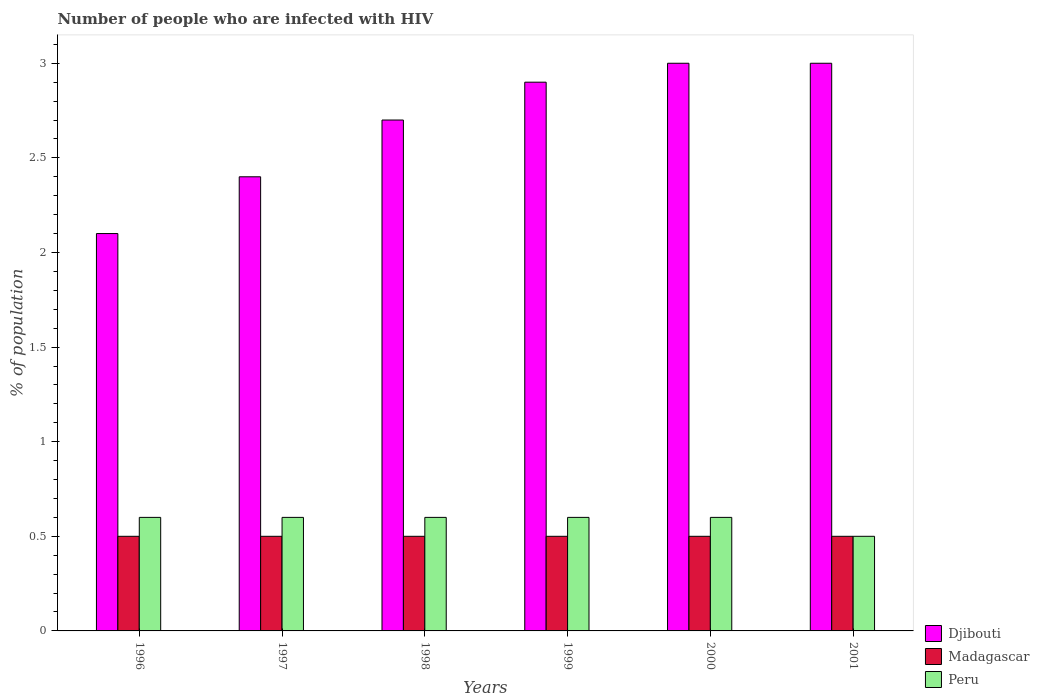How many groups of bars are there?
Your response must be concise. 6. Are the number of bars per tick equal to the number of legend labels?
Offer a terse response. Yes. How many bars are there on the 5th tick from the right?
Offer a very short reply. 3. What is the label of the 5th group of bars from the left?
Ensure brevity in your answer.  2000. Across all years, what is the maximum percentage of HIV infected population in in Madagascar?
Offer a very short reply. 0.5. Across all years, what is the minimum percentage of HIV infected population in in Peru?
Your answer should be compact. 0.5. In which year was the percentage of HIV infected population in in Djibouti maximum?
Give a very brief answer. 2000. What is the total percentage of HIV infected population in in Peru in the graph?
Your response must be concise. 3.5. What is the difference between the percentage of HIV infected population in in Peru in 1996 and that in 1997?
Offer a very short reply. 0. What is the average percentage of HIV infected population in in Peru per year?
Your response must be concise. 0.58. In the year 2000, what is the difference between the percentage of HIV infected population in in Madagascar and percentage of HIV infected population in in Djibouti?
Your answer should be very brief. -2.5. What is the ratio of the percentage of HIV infected population in in Djibouti in 1999 to that in 2001?
Your answer should be very brief. 0.97. Is the difference between the percentage of HIV infected population in in Madagascar in 1997 and 1999 greater than the difference between the percentage of HIV infected population in in Djibouti in 1997 and 1999?
Your response must be concise. Yes. What is the difference between the highest and the lowest percentage of HIV infected population in in Djibouti?
Provide a short and direct response. 0.9. In how many years, is the percentage of HIV infected population in in Djibouti greater than the average percentage of HIV infected population in in Djibouti taken over all years?
Provide a short and direct response. 4. Is the sum of the percentage of HIV infected population in in Peru in 1998 and 1999 greater than the maximum percentage of HIV infected population in in Madagascar across all years?
Ensure brevity in your answer.  Yes. What does the 2nd bar from the left in 1999 represents?
Provide a short and direct response. Madagascar. What does the 2nd bar from the right in 1996 represents?
Ensure brevity in your answer.  Madagascar. Is it the case that in every year, the sum of the percentage of HIV infected population in in Madagascar and percentage of HIV infected population in in Peru is greater than the percentage of HIV infected population in in Djibouti?
Give a very brief answer. No. How many years are there in the graph?
Make the answer very short. 6. Does the graph contain any zero values?
Give a very brief answer. No. How are the legend labels stacked?
Provide a short and direct response. Vertical. What is the title of the graph?
Make the answer very short. Number of people who are infected with HIV. What is the label or title of the X-axis?
Provide a succinct answer. Years. What is the label or title of the Y-axis?
Keep it short and to the point. % of population. What is the % of population in Djibouti in 1996?
Offer a terse response. 2.1. What is the % of population of Peru in 1996?
Your response must be concise. 0.6. What is the % of population of Djibouti in 1997?
Offer a terse response. 2.4. What is the % of population in Madagascar in 1998?
Give a very brief answer. 0.5. What is the % of population in Djibouti in 1999?
Your answer should be very brief. 2.9. What is the % of population in Peru in 1999?
Offer a terse response. 0.6. What is the % of population of Peru in 2000?
Offer a terse response. 0.6. What is the % of population in Madagascar in 2001?
Make the answer very short. 0.5. Across all years, what is the maximum % of population in Djibouti?
Ensure brevity in your answer.  3. Across all years, what is the maximum % of population in Madagascar?
Provide a short and direct response. 0.5. Across all years, what is the maximum % of population in Peru?
Make the answer very short. 0.6. Across all years, what is the minimum % of population in Madagascar?
Provide a succinct answer. 0.5. Across all years, what is the minimum % of population in Peru?
Ensure brevity in your answer.  0.5. What is the difference between the % of population of Madagascar in 1996 and that in 1997?
Provide a short and direct response. 0. What is the difference between the % of population of Djibouti in 1996 and that in 1998?
Offer a terse response. -0.6. What is the difference between the % of population of Djibouti in 1996 and that in 1999?
Offer a terse response. -0.8. What is the difference between the % of population in Djibouti in 1996 and that in 2000?
Offer a terse response. -0.9. What is the difference between the % of population in Madagascar in 1996 and that in 2000?
Your answer should be compact. 0. What is the difference between the % of population of Djibouti in 1996 and that in 2001?
Offer a very short reply. -0.9. What is the difference between the % of population of Peru in 1996 and that in 2001?
Your answer should be very brief. 0.1. What is the difference between the % of population in Djibouti in 1997 and that in 1998?
Make the answer very short. -0.3. What is the difference between the % of population in Madagascar in 1997 and that in 1998?
Offer a very short reply. 0. What is the difference between the % of population in Djibouti in 1997 and that in 2000?
Keep it short and to the point. -0.6. What is the difference between the % of population in Madagascar in 1997 and that in 2001?
Offer a terse response. 0. What is the difference between the % of population of Djibouti in 1998 and that in 1999?
Provide a succinct answer. -0.2. What is the difference between the % of population of Madagascar in 1998 and that in 1999?
Your response must be concise. 0. What is the difference between the % of population of Peru in 1998 and that in 1999?
Keep it short and to the point. 0. What is the difference between the % of population in Djibouti in 1998 and that in 2000?
Offer a very short reply. -0.3. What is the difference between the % of population of Madagascar in 1998 and that in 2000?
Provide a short and direct response. 0. What is the difference between the % of population of Peru in 1998 and that in 2001?
Your answer should be very brief. 0.1. What is the difference between the % of population in Madagascar in 1999 and that in 2000?
Your answer should be compact. 0. What is the difference between the % of population of Madagascar in 1999 and that in 2001?
Keep it short and to the point. 0. What is the difference between the % of population in Peru in 2000 and that in 2001?
Offer a terse response. 0.1. What is the difference between the % of population of Djibouti in 1996 and the % of population of Madagascar in 1997?
Offer a terse response. 1.6. What is the difference between the % of population of Djibouti in 1996 and the % of population of Madagascar in 1998?
Your answer should be compact. 1.6. What is the difference between the % of population in Djibouti in 1996 and the % of population in Peru in 1998?
Your answer should be very brief. 1.5. What is the difference between the % of population of Madagascar in 1996 and the % of population of Peru in 1998?
Your answer should be very brief. -0.1. What is the difference between the % of population of Madagascar in 1996 and the % of population of Peru in 1999?
Offer a very short reply. -0.1. What is the difference between the % of population of Djibouti in 1996 and the % of population of Madagascar in 2000?
Offer a terse response. 1.6. What is the difference between the % of population of Djibouti in 1996 and the % of population of Peru in 2000?
Provide a short and direct response. 1.5. What is the difference between the % of population in Djibouti in 1996 and the % of population in Peru in 2001?
Ensure brevity in your answer.  1.6. What is the difference between the % of population in Djibouti in 1997 and the % of population in Madagascar in 1998?
Your answer should be compact. 1.9. What is the difference between the % of population of Djibouti in 1997 and the % of population of Peru in 1998?
Offer a terse response. 1.8. What is the difference between the % of population of Djibouti in 1997 and the % of population of Peru in 1999?
Keep it short and to the point. 1.8. What is the difference between the % of population of Djibouti in 1997 and the % of population of Madagascar in 2000?
Your answer should be compact. 1.9. What is the difference between the % of population of Djibouti in 1997 and the % of population of Peru in 2000?
Provide a short and direct response. 1.8. What is the difference between the % of population in Madagascar in 1997 and the % of population in Peru in 2000?
Offer a terse response. -0.1. What is the difference between the % of population in Madagascar in 1998 and the % of population in Peru in 1999?
Ensure brevity in your answer.  -0.1. What is the difference between the % of population in Djibouti in 1998 and the % of population in Peru in 2000?
Your answer should be very brief. 2.1. What is the difference between the % of population in Madagascar in 1998 and the % of population in Peru in 2000?
Your response must be concise. -0.1. What is the difference between the % of population of Djibouti in 1998 and the % of population of Peru in 2001?
Make the answer very short. 2.2. What is the difference between the % of population in Djibouti in 1999 and the % of population in Peru in 2000?
Keep it short and to the point. 2.3. What is the difference between the % of population of Djibouti in 1999 and the % of population of Madagascar in 2001?
Your answer should be compact. 2.4. What is the difference between the % of population in Djibouti in 1999 and the % of population in Peru in 2001?
Provide a short and direct response. 2.4. What is the difference between the % of population of Madagascar in 1999 and the % of population of Peru in 2001?
Give a very brief answer. 0. What is the difference between the % of population in Djibouti in 2000 and the % of population in Peru in 2001?
Your answer should be very brief. 2.5. What is the difference between the % of population of Madagascar in 2000 and the % of population of Peru in 2001?
Ensure brevity in your answer.  0. What is the average % of population in Djibouti per year?
Make the answer very short. 2.68. What is the average % of population of Peru per year?
Keep it short and to the point. 0.58. In the year 1996, what is the difference between the % of population in Madagascar and % of population in Peru?
Offer a very short reply. -0.1. In the year 1997, what is the difference between the % of population of Djibouti and % of population of Peru?
Your answer should be very brief. 1.8. In the year 1998, what is the difference between the % of population of Madagascar and % of population of Peru?
Your answer should be compact. -0.1. In the year 1999, what is the difference between the % of population in Djibouti and % of population in Madagascar?
Keep it short and to the point. 2.4. In the year 1999, what is the difference between the % of population of Djibouti and % of population of Peru?
Offer a terse response. 2.3. In the year 2000, what is the difference between the % of population of Djibouti and % of population of Madagascar?
Keep it short and to the point. 2.5. In the year 2000, what is the difference between the % of population of Djibouti and % of population of Peru?
Give a very brief answer. 2.4. In the year 2001, what is the difference between the % of population in Djibouti and % of population in Madagascar?
Offer a very short reply. 2.5. What is the ratio of the % of population of Madagascar in 1996 to that in 1997?
Offer a very short reply. 1. What is the ratio of the % of population of Peru in 1996 to that in 1997?
Your response must be concise. 1. What is the ratio of the % of population of Djibouti in 1996 to that in 1998?
Provide a short and direct response. 0.78. What is the ratio of the % of population in Peru in 1996 to that in 1998?
Your answer should be compact. 1. What is the ratio of the % of population in Djibouti in 1996 to that in 1999?
Provide a succinct answer. 0.72. What is the ratio of the % of population in Madagascar in 1996 to that in 1999?
Offer a very short reply. 1. What is the ratio of the % of population of Madagascar in 1996 to that in 2000?
Give a very brief answer. 1. What is the ratio of the % of population in Djibouti in 1996 to that in 2001?
Ensure brevity in your answer.  0.7. What is the ratio of the % of population of Madagascar in 1996 to that in 2001?
Your response must be concise. 1. What is the ratio of the % of population of Djibouti in 1997 to that in 1998?
Give a very brief answer. 0.89. What is the ratio of the % of population in Madagascar in 1997 to that in 1998?
Your response must be concise. 1. What is the ratio of the % of population in Djibouti in 1997 to that in 1999?
Ensure brevity in your answer.  0.83. What is the ratio of the % of population in Madagascar in 1997 to that in 1999?
Your answer should be very brief. 1. What is the ratio of the % of population of Peru in 1997 to that in 1999?
Offer a very short reply. 1. What is the ratio of the % of population of Madagascar in 1997 to that in 2000?
Ensure brevity in your answer.  1. What is the ratio of the % of population of Madagascar in 1997 to that in 2001?
Offer a terse response. 1. What is the ratio of the % of population of Peru in 1997 to that in 2001?
Give a very brief answer. 1.2. What is the ratio of the % of population of Peru in 1998 to that in 1999?
Provide a succinct answer. 1. What is the ratio of the % of population in Djibouti in 1998 to that in 2000?
Provide a short and direct response. 0.9. What is the ratio of the % of population in Madagascar in 1998 to that in 2000?
Provide a short and direct response. 1. What is the ratio of the % of population of Djibouti in 1998 to that in 2001?
Give a very brief answer. 0.9. What is the ratio of the % of population in Madagascar in 1998 to that in 2001?
Give a very brief answer. 1. What is the ratio of the % of population in Peru in 1998 to that in 2001?
Ensure brevity in your answer.  1.2. What is the ratio of the % of population of Djibouti in 1999 to that in 2000?
Your answer should be very brief. 0.97. What is the ratio of the % of population in Madagascar in 1999 to that in 2000?
Offer a very short reply. 1. What is the ratio of the % of population of Djibouti in 1999 to that in 2001?
Make the answer very short. 0.97. What is the ratio of the % of population of Madagascar in 1999 to that in 2001?
Offer a very short reply. 1. What is the ratio of the % of population of Peru in 1999 to that in 2001?
Offer a very short reply. 1.2. What is the ratio of the % of population in Peru in 2000 to that in 2001?
Your response must be concise. 1.2. What is the difference between the highest and the second highest % of population of Madagascar?
Provide a short and direct response. 0. What is the difference between the highest and the second highest % of population in Peru?
Provide a succinct answer. 0. What is the difference between the highest and the lowest % of population of Djibouti?
Offer a very short reply. 0.9. What is the difference between the highest and the lowest % of population in Peru?
Ensure brevity in your answer.  0.1. 